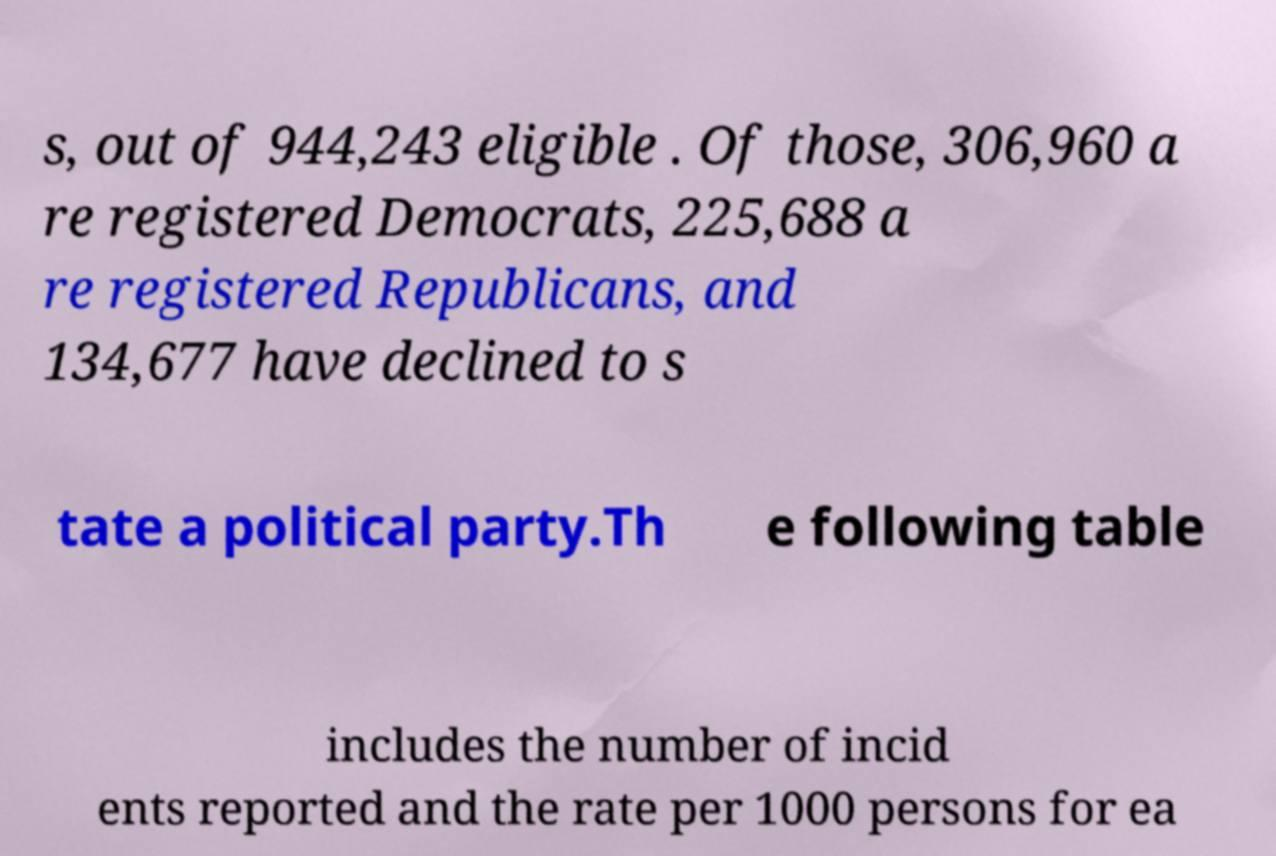I need the written content from this picture converted into text. Can you do that? s, out of 944,243 eligible . Of those, 306,960 a re registered Democrats, 225,688 a re registered Republicans, and 134,677 have declined to s tate a political party.Th e following table includes the number of incid ents reported and the rate per 1000 persons for ea 